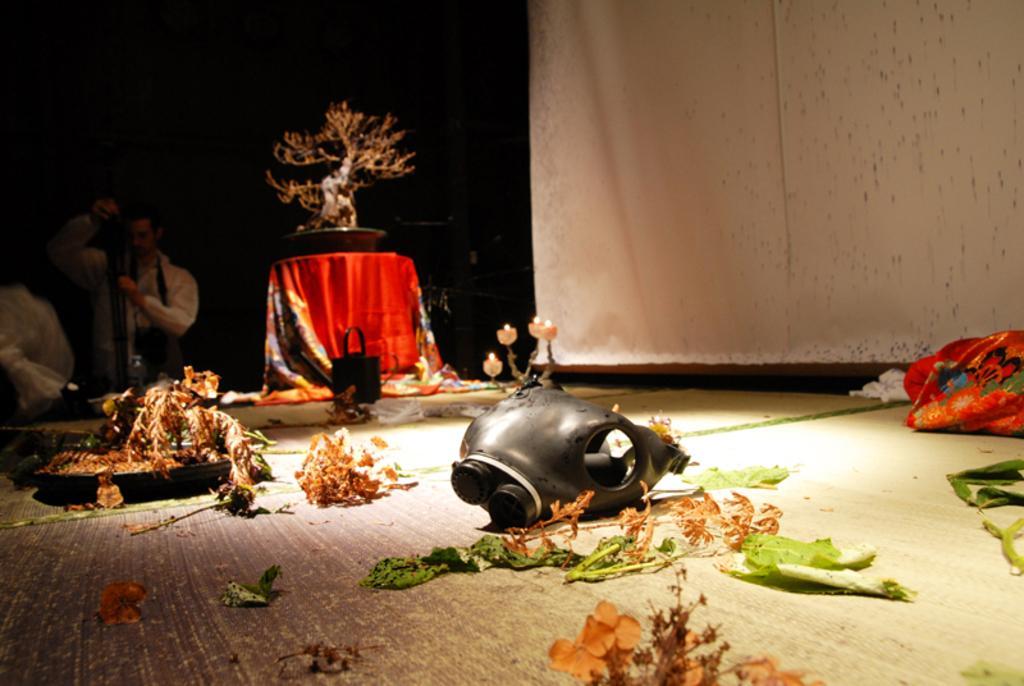Please provide a concise description of this image. In the image we can see there are dry leaves and plants on the floor and there is a mask kept on the floor. Behind there is a dry bonsai kept on the table and there is a man standing. There are candles kept on the stand. 